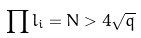Convert formula to latex. <formula><loc_0><loc_0><loc_500><loc_500>\prod l _ { i } = N > 4 \sqrt { q }</formula> 